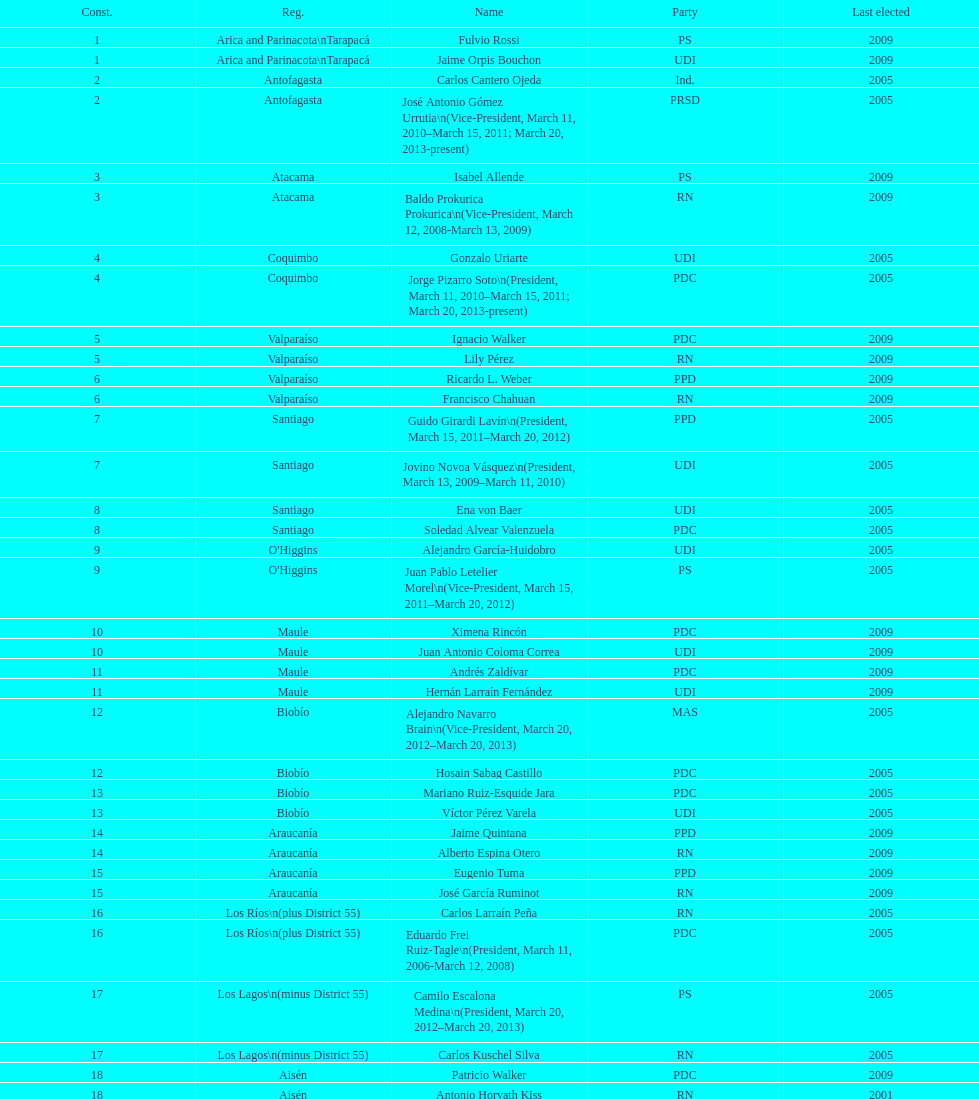Help me parse the entirety of this table. {'header': ['Const.', 'Reg.', 'Name', 'Party', 'Last elected'], 'rows': [['1', 'Arica and Parinacota\\nTarapacá', 'Fulvio Rossi', 'PS', '2009'], ['1', 'Arica and Parinacota\\nTarapacá', 'Jaime Orpis Bouchon', 'UDI', '2009'], ['2', 'Antofagasta', 'Carlos Cantero Ojeda', 'Ind.', '2005'], ['2', 'Antofagasta', 'José Antonio Gómez Urrutia\\n(Vice-President, March 11, 2010–March 15, 2011; March 20, 2013-present)', 'PRSD', '2005'], ['3', 'Atacama', 'Isabel Allende', 'PS', '2009'], ['3', 'Atacama', 'Baldo Prokurica Prokurica\\n(Vice-President, March 12, 2008-March 13, 2009)', 'RN', '2009'], ['4', 'Coquimbo', 'Gonzalo Uriarte', 'UDI', '2005'], ['4', 'Coquimbo', 'Jorge Pizarro Soto\\n(President, March 11, 2010–March 15, 2011; March 20, 2013-present)', 'PDC', '2005'], ['5', 'Valparaíso', 'Ignacio Walker', 'PDC', '2009'], ['5', 'Valparaíso', 'Lily Pérez', 'RN', '2009'], ['6', 'Valparaíso', 'Ricardo L. Weber', 'PPD', '2009'], ['6', 'Valparaíso', 'Francisco Chahuan', 'RN', '2009'], ['7', 'Santiago', 'Guido Girardi Lavín\\n(President, March 15, 2011–March 20, 2012)', 'PPD', '2005'], ['7', 'Santiago', 'Jovino Novoa Vásquez\\n(President, March 13, 2009–March 11, 2010)', 'UDI', '2005'], ['8', 'Santiago', 'Ena von Baer', 'UDI', '2005'], ['8', 'Santiago', 'Soledad Alvear Valenzuela', 'PDC', '2005'], ['9', "O'Higgins", 'Alejandro García-Huidobro', 'UDI', '2005'], ['9', "O'Higgins", 'Juan Pablo Letelier Morel\\n(Vice-President, March 15, 2011–March 20, 2012)', 'PS', '2005'], ['10', 'Maule', 'Ximena Rincón', 'PDC', '2009'], ['10', 'Maule', 'Juan Antonio Coloma Correa', 'UDI', '2009'], ['11', 'Maule', 'Andrés Zaldívar', 'PDC', '2009'], ['11', 'Maule', 'Hernán Larraín Fernández', 'UDI', '2009'], ['12', 'Biobío', 'Alejandro Navarro Brain\\n(Vice-President, March 20, 2012–March 20, 2013)', 'MAS', '2005'], ['12', 'Biobío', 'Hosain Sabag Castillo', 'PDC', '2005'], ['13', 'Biobío', 'Mariano Ruiz-Esquide Jara', 'PDC', '2005'], ['13', 'Biobío', 'Víctor Pérez Varela', 'UDI', '2005'], ['14', 'Araucanía', 'Jaime Quintana', 'PPD', '2009'], ['14', 'Araucanía', 'Alberto Espina Otero', 'RN', '2009'], ['15', 'Araucanía', 'Eugenio Tuma', 'PPD', '2009'], ['15', 'Araucanía', 'José García Ruminot', 'RN', '2009'], ['16', 'Los Ríos\\n(plus District 55)', 'Carlos Larraín Peña', 'RN', '2005'], ['16', 'Los Ríos\\n(plus District 55)', 'Eduardo Frei Ruiz-Tagle\\n(President, March 11, 2006-March 12, 2008)', 'PDC', '2005'], ['17', 'Los Lagos\\n(minus District 55)', 'Camilo Escalona Medina\\n(President, March 20, 2012–March 20, 2013)', 'PS', '2005'], ['17', 'Los Lagos\\n(minus District 55)', 'Carlos Kuschel Silva', 'RN', '2005'], ['18', 'Aisén', 'Patricio Walker', 'PDC', '2009'], ['18', 'Aisén', 'Antonio Horvath Kiss', 'RN', '2001'], ['19', 'Magallanes', 'Carlos Bianchi Chelech\\n(Vice-President, March 13, 2009–March 11, 2010)', 'Ind.', '2005'], ['19', 'Magallanes', 'Pedro Muñoz Aburto', 'PS', '2005']]} How many total consituency are listed in the table? 19. 